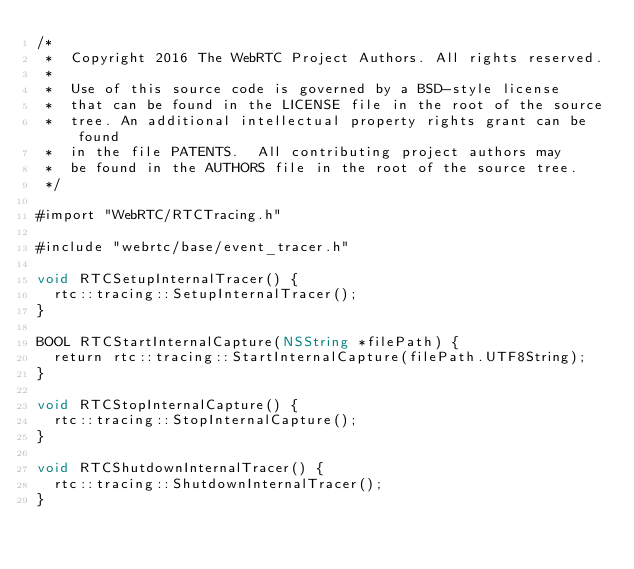<code> <loc_0><loc_0><loc_500><loc_500><_ObjectiveC_>/*
 *  Copyright 2016 The WebRTC Project Authors. All rights reserved.
 *
 *  Use of this source code is governed by a BSD-style license
 *  that can be found in the LICENSE file in the root of the source
 *  tree. An additional intellectual property rights grant can be found
 *  in the file PATENTS.  All contributing project authors may
 *  be found in the AUTHORS file in the root of the source tree.
 */

#import "WebRTC/RTCTracing.h"

#include "webrtc/base/event_tracer.h"

void RTCSetupInternalTracer() {
  rtc::tracing::SetupInternalTracer();
}

BOOL RTCStartInternalCapture(NSString *filePath) {
  return rtc::tracing::StartInternalCapture(filePath.UTF8String);
}

void RTCStopInternalCapture() {
  rtc::tracing::StopInternalCapture();
}

void RTCShutdownInternalTracer() {
  rtc::tracing::ShutdownInternalTracer();
}
</code> 